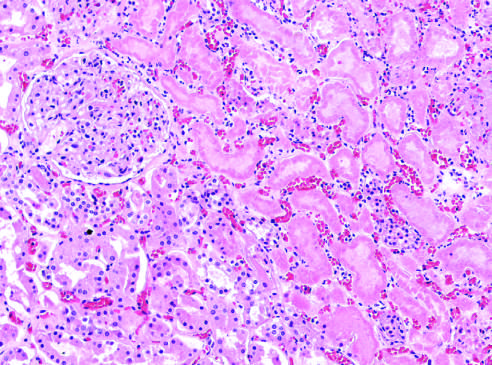do necrotic cells show preserved outlines with loss of nuclei, and an inflammatory infiltrate is present (difficult to discern at this magnification)?
Answer the question using a single word or phrase. Yes 